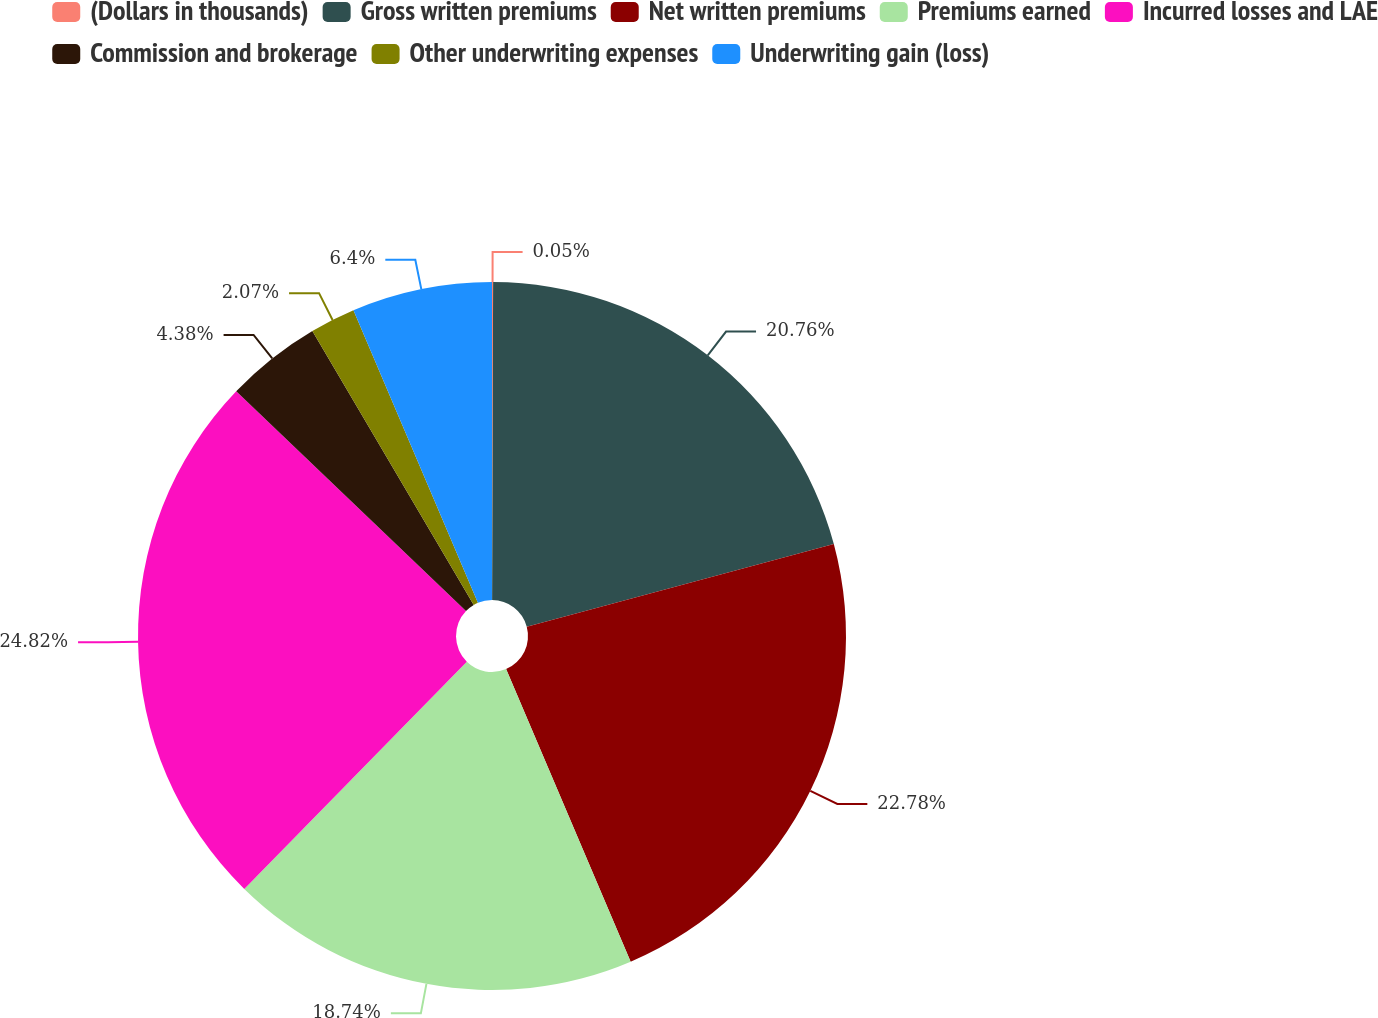Convert chart. <chart><loc_0><loc_0><loc_500><loc_500><pie_chart><fcel>(Dollars in thousands)<fcel>Gross written premiums<fcel>Net written premiums<fcel>Premiums earned<fcel>Incurred losses and LAE<fcel>Commission and brokerage<fcel>Other underwriting expenses<fcel>Underwriting gain (loss)<nl><fcel>0.05%<fcel>20.76%<fcel>22.78%<fcel>18.74%<fcel>24.81%<fcel>4.38%<fcel>2.07%<fcel>6.4%<nl></chart> 